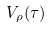<formula> <loc_0><loc_0><loc_500><loc_500>V _ { \rho } ( \tau )</formula> 